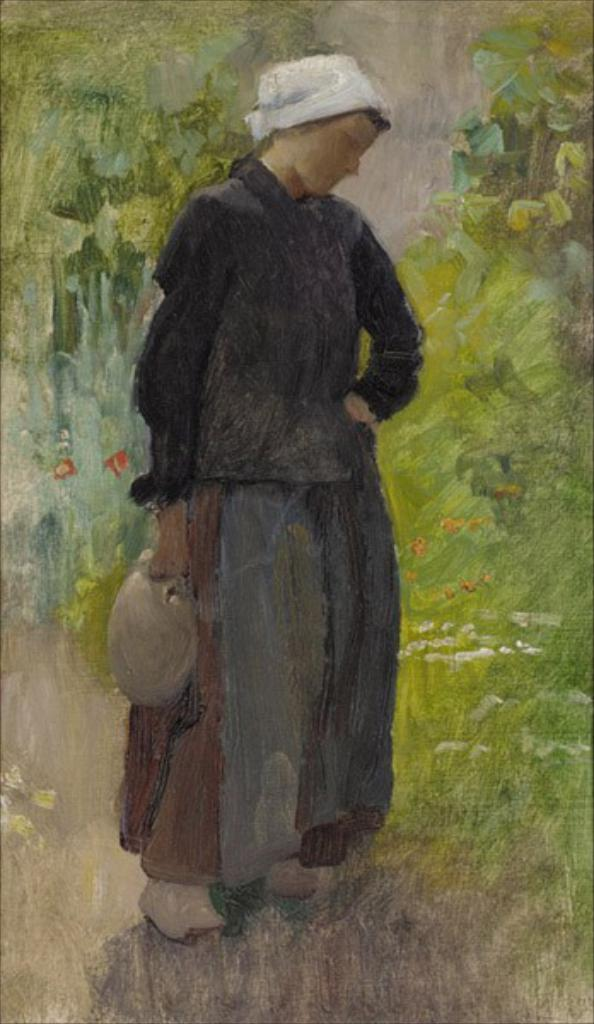What is the main subject of the painting? The painting depicts a woman. What is the woman wearing in the painting? The woman is wearing a black dress in the painting. Where is the woman located in the painting? The woman is standing in the ground in the painting. What can be seen in the background of the painting? There are green plants visible in the background of the painting. Can you see a crown on the woman's head in the painting? No, there is no crown visible on the woman's head in the painting. Is the woman holding a stick in the painting? No, the woman is not holding a stick in the painting. 